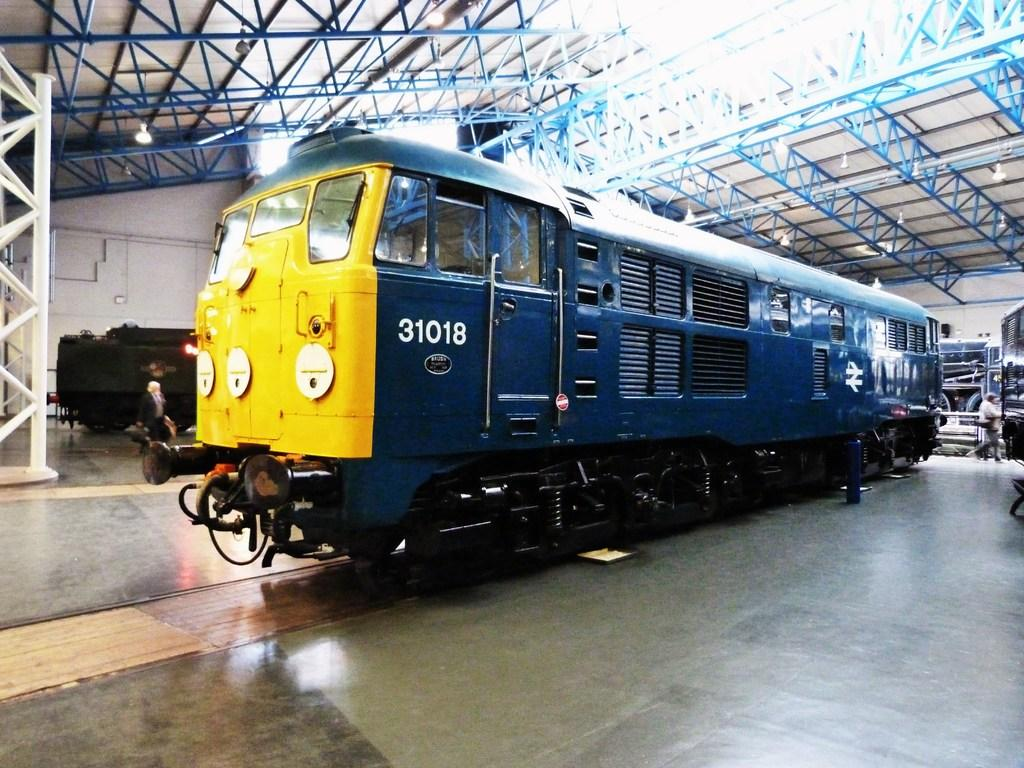<image>
Summarize the visual content of the image. A blue and yellow train is parked in an indoor garage and it says 31018 on the side. 